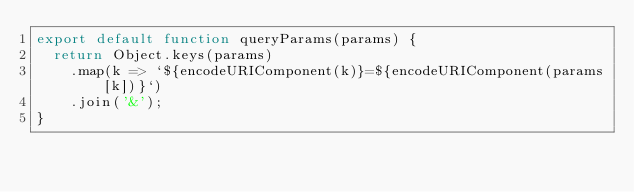<code> <loc_0><loc_0><loc_500><loc_500><_JavaScript_>export default function queryParams(params) {
  return Object.keys(params)
    .map(k => `${encodeURIComponent(k)}=${encodeURIComponent(params[k])}`)
    .join('&');
}
</code> 